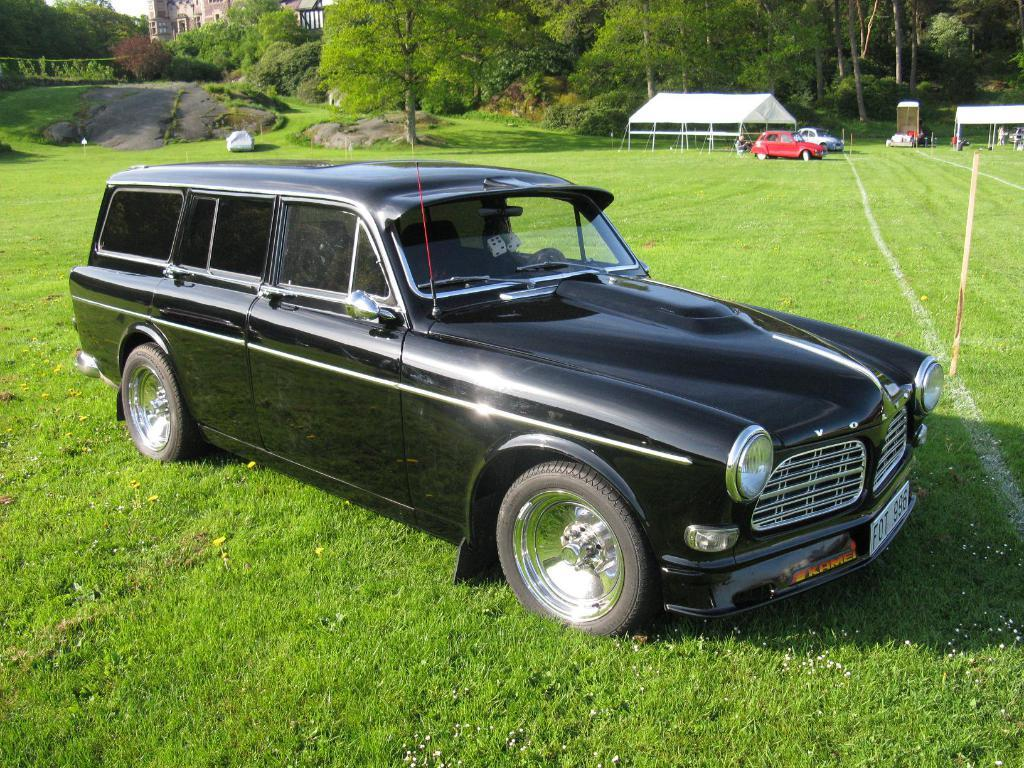What is the main subject of the image? There is a car in the image. What type of terrain is visible in the image? There is grass on the ground in the image. What animals can be seen in the back of the image? There are cats in the back of the image. What structures are visible in the back of the image? There is a shed, trees, rocks, and a building in the back of the image. What type of crate is being used to store the celery in the image? There is no crate or celery present in the image. 